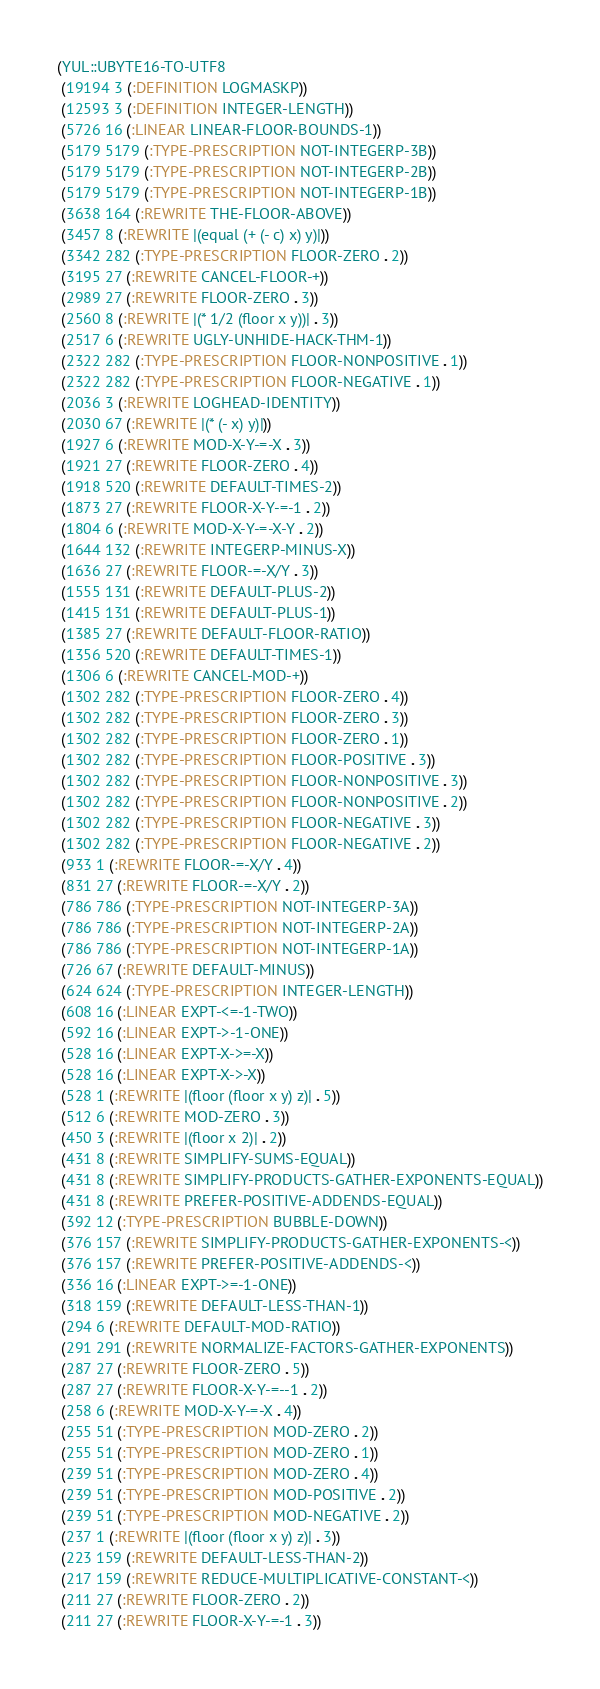<code> <loc_0><loc_0><loc_500><loc_500><_Lisp_>(YUL::UBYTE16-TO-UTF8
 (19194 3 (:DEFINITION LOGMASKP))
 (12593 3 (:DEFINITION INTEGER-LENGTH))
 (5726 16 (:LINEAR LINEAR-FLOOR-BOUNDS-1))
 (5179 5179 (:TYPE-PRESCRIPTION NOT-INTEGERP-3B))
 (5179 5179 (:TYPE-PRESCRIPTION NOT-INTEGERP-2B))
 (5179 5179 (:TYPE-PRESCRIPTION NOT-INTEGERP-1B))
 (3638 164 (:REWRITE THE-FLOOR-ABOVE))
 (3457 8 (:REWRITE |(equal (+ (- c) x) y)|))
 (3342 282 (:TYPE-PRESCRIPTION FLOOR-ZERO . 2))
 (3195 27 (:REWRITE CANCEL-FLOOR-+))
 (2989 27 (:REWRITE FLOOR-ZERO . 3))
 (2560 8 (:REWRITE |(* 1/2 (floor x y))| . 3))
 (2517 6 (:REWRITE UGLY-UNHIDE-HACK-THM-1))
 (2322 282 (:TYPE-PRESCRIPTION FLOOR-NONPOSITIVE . 1))
 (2322 282 (:TYPE-PRESCRIPTION FLOOR-NEGATIVE . 1))
 (2036 3 (:REWRITE LOGHEAD-IDENTITY))
 (2030 67 (:REWRITE |(* (- x) y)|))
 (1927 6 (:REWRITE MOD-X-Y-=-X . 3))
 (1921 27 (:REWRITE FLOOR-ZERO . 4))
 (1918 520 (:REWRITE DEFAULT-TIMES-2))
 (1873 27 (:REWRITE FLOOR-X-Y-=-1 . 2))
 (1804 6 (:REWRITE MOD-X-Y-=-X-Y . 2))
 (1644 132 (:REWRITE INTEGERP-MINUS-X))
 (1636 27 (:REWRITE FLOOR-=-X/Y . 3))
 (1555 131 (:REWRITE DEFAULT-PLUS-2))
 (1415 131 (:REWRITE DEFAULT-PLUS-1))
 (1385 27 (:REWRITE DEFAULT-FLOOR-RATIO))
 (1356 520 (:REWRITE DEFAULT-TIMES-1))
 (1306 6 (:REWRITE CANCEL-MOD-+))
 (1302 282 (:TYPE-PRESCRIPTION FLOOR-ZERO . 4))
 (1302 282 (:TYPE-PRESCRIPTION FLOOR-ZERO . 3))
 (1302 282 (:TYPE-PRESCRIPTION FLOOR-ZERO . 1))
 (1302 282 (:TYPE-PRESCRIPTION FLOOR-POSITIVE . 3))
 (1302 282 (:TYPE-PRESCRIPTION FLOOR-NONPOSITIVE . 3))
 (1302 282 (:TYPE-PRESCRIPTION FLOOR-NONPOSITIVE . 2))
 (1302 282 (:TYPE-PRESCRIPTION FLOOR-NEGATIVE . 3))
 (1302 282 (:TYPE-PRESCRIPTION FLOOR-NEGATIVE . 2))
 (933 1 (:REWRITE FLOOR-=-X/Y . 4))
 (831 27 (:REWRITE FLOOR-=-X/Y . 2))
 (786 786 (:TYPE-PRESCRIPTION NOT-INTEGERP-3A))
 (786 786 (:TYPE-PRESCRIPTION NOT-INTEGERP-2A))
 (786 786 (:TYPE-PRESCRIPTION NOT-INTEGERP-1A))
 (726 67 (:REWRITE DEFAULT-MINUS))
 (624 624 (:TYPE-PRESCRIPTION INTEGER-LENGTH))
 (608 16 (:LINEAR EXPT-<=-1-TWO))
 (592 16 (:LINEAR EXPT->-1-ONE))
 (528 16 (:LINEAR EXPT-X->=-X))
 (528 16 (:LINEAR EXPT-X->-X))
 (528 1 (:REWRITE |(floor (floor x y) z)| . 5))
 (512 6 (:REWRITE MOD-ZERO . 3))
 (450 3 (:REWRITE |(floor x 2)| . 2))
 (431 8 (:REWRITE SIMPLIFY-SUMS-EQUAL))
 (431 8 (:REWRITE SIMPLIFY-PRODUCTS-GATHER-EXPONENTS-EQUAL))
 (431 8 (:REWRITE PREFER-POSITIVE-ADDENDS-EQUAL))
 (392 12 (:TYPE-PRESCRIPTION BUBBLE-DOWN))
 (376 157 (:REWRITE SIMPLIFY-PRODUCTS-GATHER-EXPONENTS-<))
 (376 157 (:REWRITE PREFER-POSITIVE-ADDENDS-<))
 (336 16 (:LINEAR EXPT->=-1-ONE))
 (318 159 (:REWRITE DEFAULT-LESS-THAN-1))
 (294 6 (:REWRITE DEFAULT-MOD-RATIO))
 (291 291 (:REWRITE NORMALIZE-FACTORS-GATHER-EXPONENTS))
 (287 27 (:REWRITE FLOOR-ZERO . 5))
 (287 27 (:REWRITE FLOOR-X-Y-=--1 . 2))
 (258 6 (:REWRITE MOD-X-Y-=-X . 4))
 (255 51 (:TYPE-PRESCRIPTION MOD-ZERO . 2))
 (255 51 (:TYPE-PRESCRIPTION MOD-ZERO . 1))
 (239 51 (:TYPE-PRESCRIPTION MOD-ZERO . 4))
 (239 51 (:TYPE-PRESCRIPTION MOD-POSITIVE . 2))
 (239 51 (:TYPE-PRESCRIPTION MOD-NEGATIVE . 2))
 (237 1 (:REWRITE |(floor (floor x y) z)| . 3))
 (223 159 (:REWRITE DEFAULT-LESS-THAN-2))
 (217 159 (:REWRITE REDUCE-MULTIPLICATIVE-CONSTANT-<))
 (211 27 (:REWRITE FLOOR-ZERO . 2))
 (211 27 (:REWRITE FLOOR-X-Y-=-1 . 3))</code> 